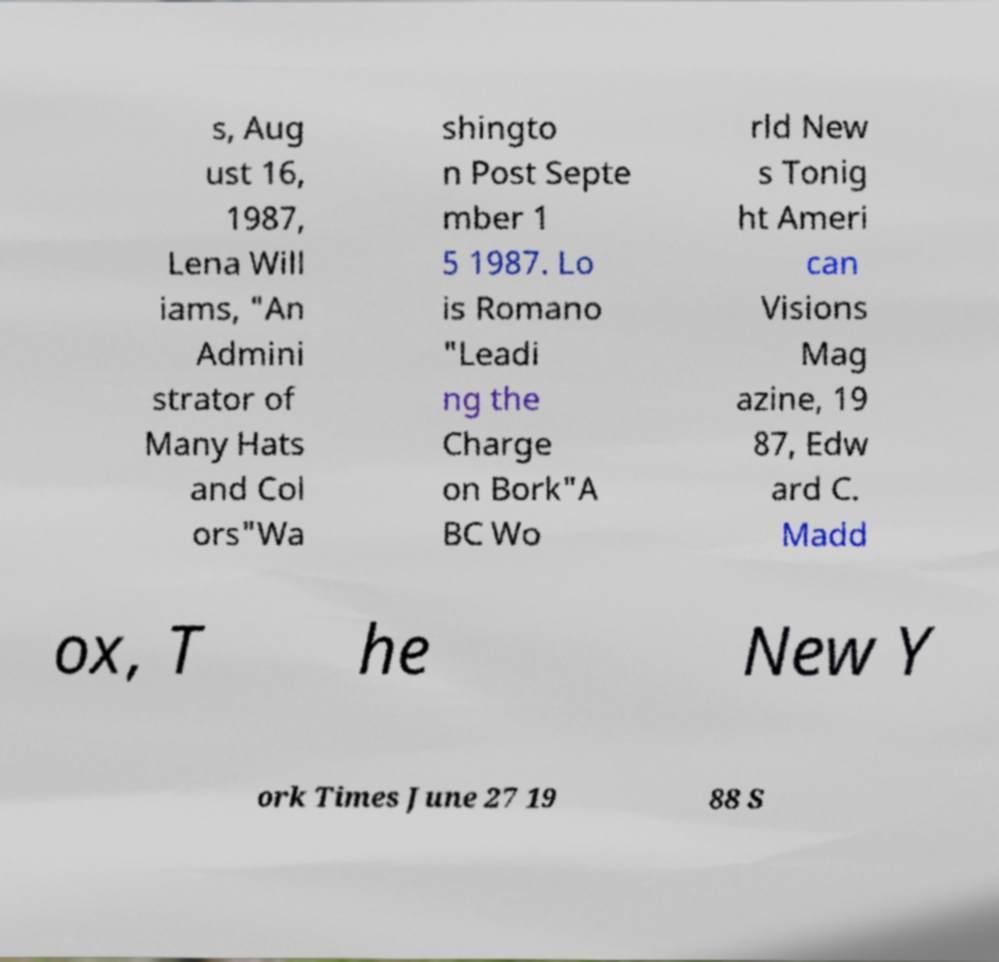There's text embedded in this image that I need extracted. Can you transcribe it verbatim? s, Aug ust 16, 1987, Lena Will iams, "An Admini strator of Many Hats and Col ors"Wa shingto n Post Septe mber 1 5 1987. Lo is Romano "Leadi ng the Charge on Bork"A BC Wo rld New s Tonig ht Ameri can Visions Mag azine, 19 87, Edw ard C. Madd ox, T he New Y ork Times June 27 19 88 S 